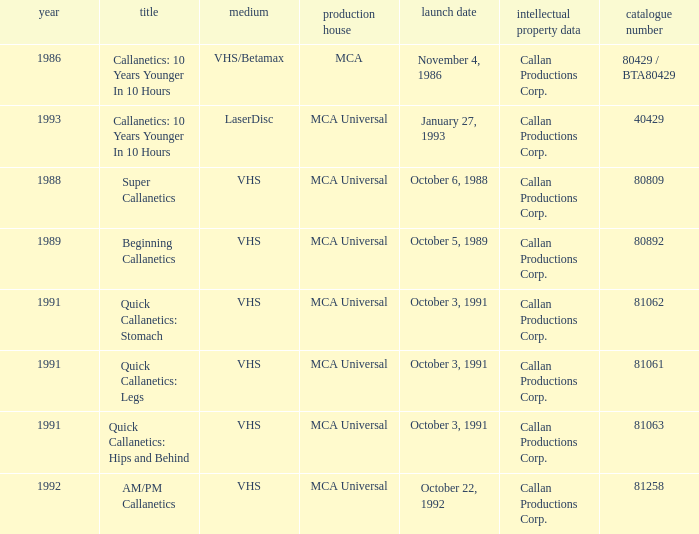Name the studio for super callanetics MCA Universal. 